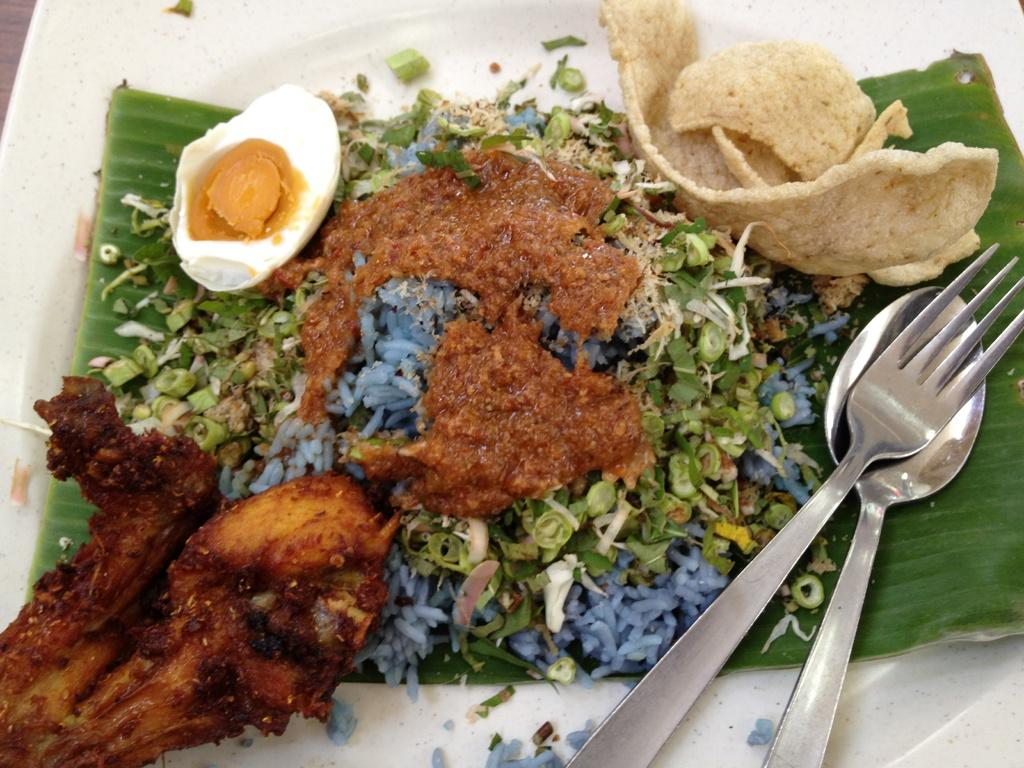What is on the plate in the image? There is a banana leaf on the plate. What is placed on the banana leaf? There is an egg and meat on the banana leaf, along with other food items. What utensils are visible in the image? There is a spoon and a fork in the image. What type of spy equipment can be seen on the banana leaf in the image? There is no spy equipment present on the banana leaf in the image. 